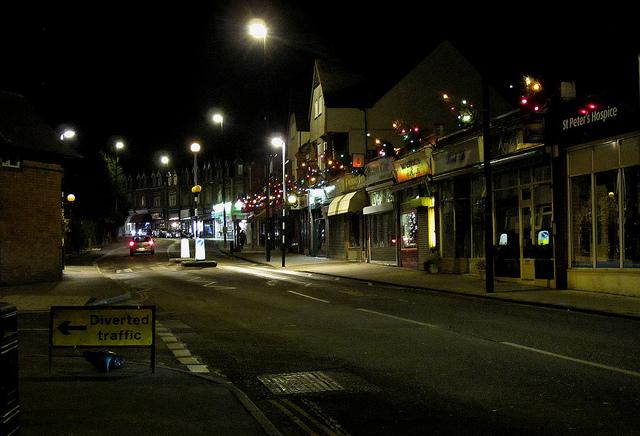Is it daytime?
Be succinct. No. How many lights are in the picture?
Write a very short answer. 7. What is the color of the writing?
Concise answer only. Black. Is the ground damp?
Quick response, please. No. Is it nighttime?
Concise answer only. Yes. What do the big letters spell?
Write a very short answer. Diverted traffic. Is the street empty?
Keep it brief. No. What color is the road?
Write a very short answer. Black. Where should diverted traffic go?
Keep it brief. Left. 